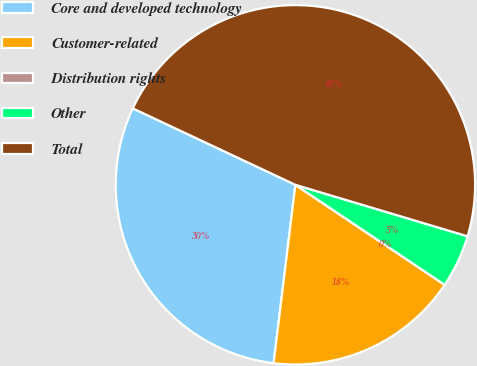<chart> <loc_0><loc_0><loc_500><loc_500><pie_chart><fcel>Core and developed technology<fcel>Customer-related<fcel>Distribution rights<fcel>Other<fcel>Total<nl><fcel>30.06%<fcel>17.54%<fcel>0.0%<fcel>4.77%<fcel>47.63%<nl></chart> 